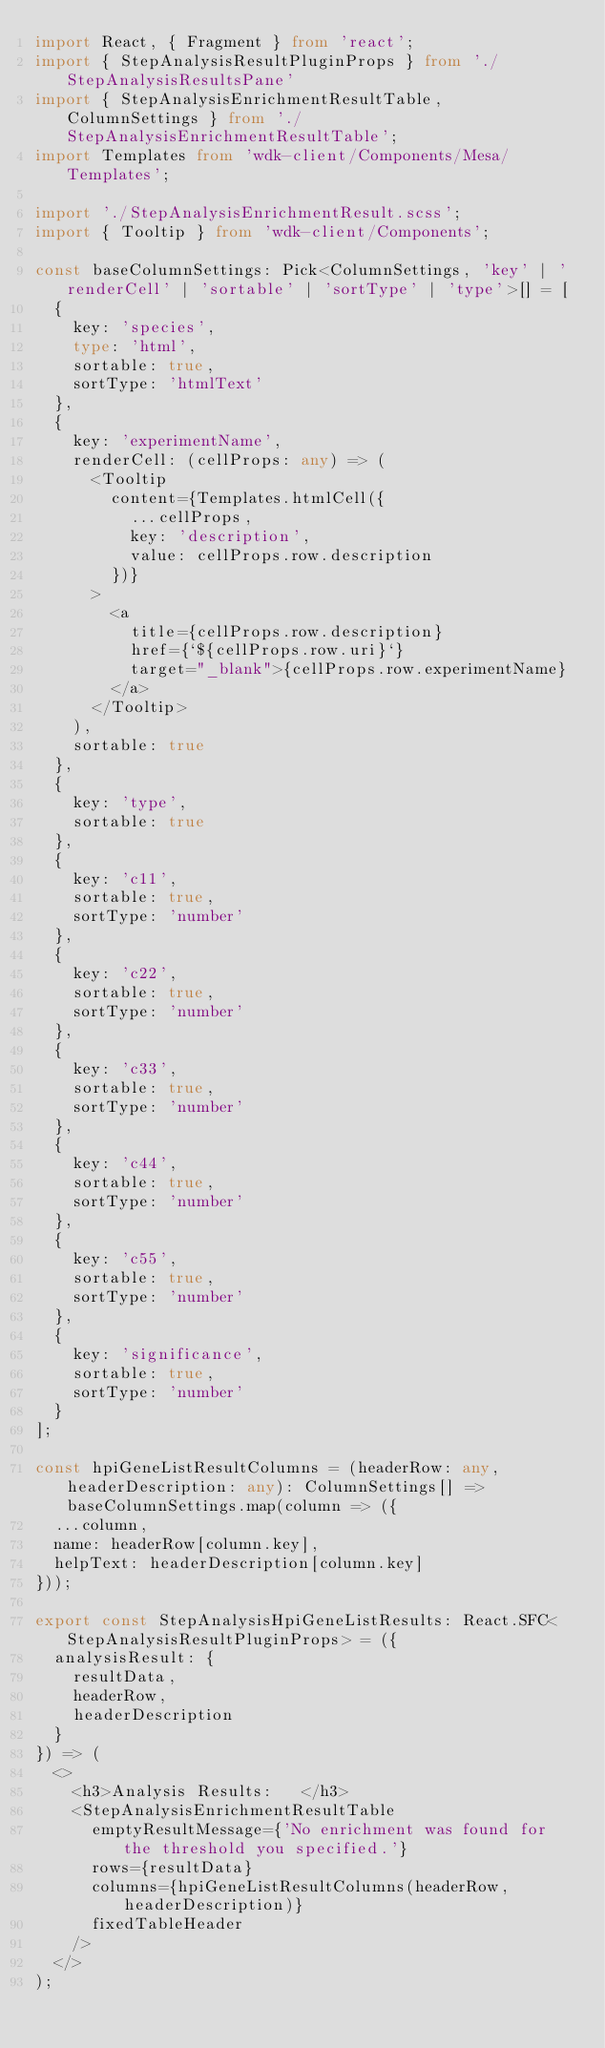Convert code to text. <code><loc_0><loc_0><loc_500><loc_500><_TypeScript_>import React, { Fragment } from 'react';
import { StepAnalysisResultPluginProps } from './StepAnalysisResultsPane'
import { StepAnalysisEnrichmentResultTable, ColumnSettings } from './StepAnalysisEnrichmentResultTable';
import Templates from 'wdk-client/Components/Mesa/Templates';

import './StepAnalysisEnrichmentResult.scss';
import { Tooltip } from 'wdk-client/Components';

const baseColumnSettings: Pick<ColumnSettings, 'key' | 'renderCell' | 'sortable' | 'sortType' | 'type'>[] = [
  {
    key: 'species',
    type: 'html',
    sortable: true,
    sortType: 'htmlText'
  },
  {
    key: 'experimentName',
    renderCell: (cellProps: any) => (
      <Tooltip
        content={Templates.htmlCell({
          ...cellProps,
          key: 'description',
          value: cellProps.row.description
        })}
      >
        <a 
          title={cellProps.row.description} 
          href={`${cellProps.row.uri}`} 
          target="_blank">{cellProps.row.experimentName}
        </a>
      </Tooltip>
    ),
    sortable: true
  },
  {
    key: 'type',
    sortable: true
  },
  {
    key: 'c11',
    sortable: true,
    sortType: 'number'
  },
  {
    key: 'c22',
    sortable: true,
    sortType: 'number'
  },
  {
    key: 'c33',
    sortable: true,
    sortType: 'number'
  },
  {
    key: 'c44',
    sortable: true,
    sortType: 'number'
  },
  {
    key: 'c55',
    sortable: true,
    sortType: 'number'
  },
  {
    key: 'significance',
    sortable: true,
    sortType: 'number'
  }
];

const hpiGeneListResultColumns = (headerRow: any, headerDescription: any): ColumnSettings[] => baseColumnSettings.map(column => ({
  ...column,
  name: headerRow[column.key],
  helpText: headerDescription[column.key]
}));

export const StepAnalysisHpiGeneListResults: React.SFC<StepAnalysisResultPluginProps> = ({
  analysisResult: {
    resultData,
    headerRow,
    headerDescription
  }
}) => (
  <>
    <h3>Analysis Results:   </h3>
    <StepAnalysisEnrichmentResultTable
      emptyResultMessage={'No enrichment was found for the threshold you specified.'}
      rows={resultData}
      columns={hpiGeneListResultColumns(headerRow, headerDescription)}
      fixedTableHeader
    />
  </>
);
</code> 